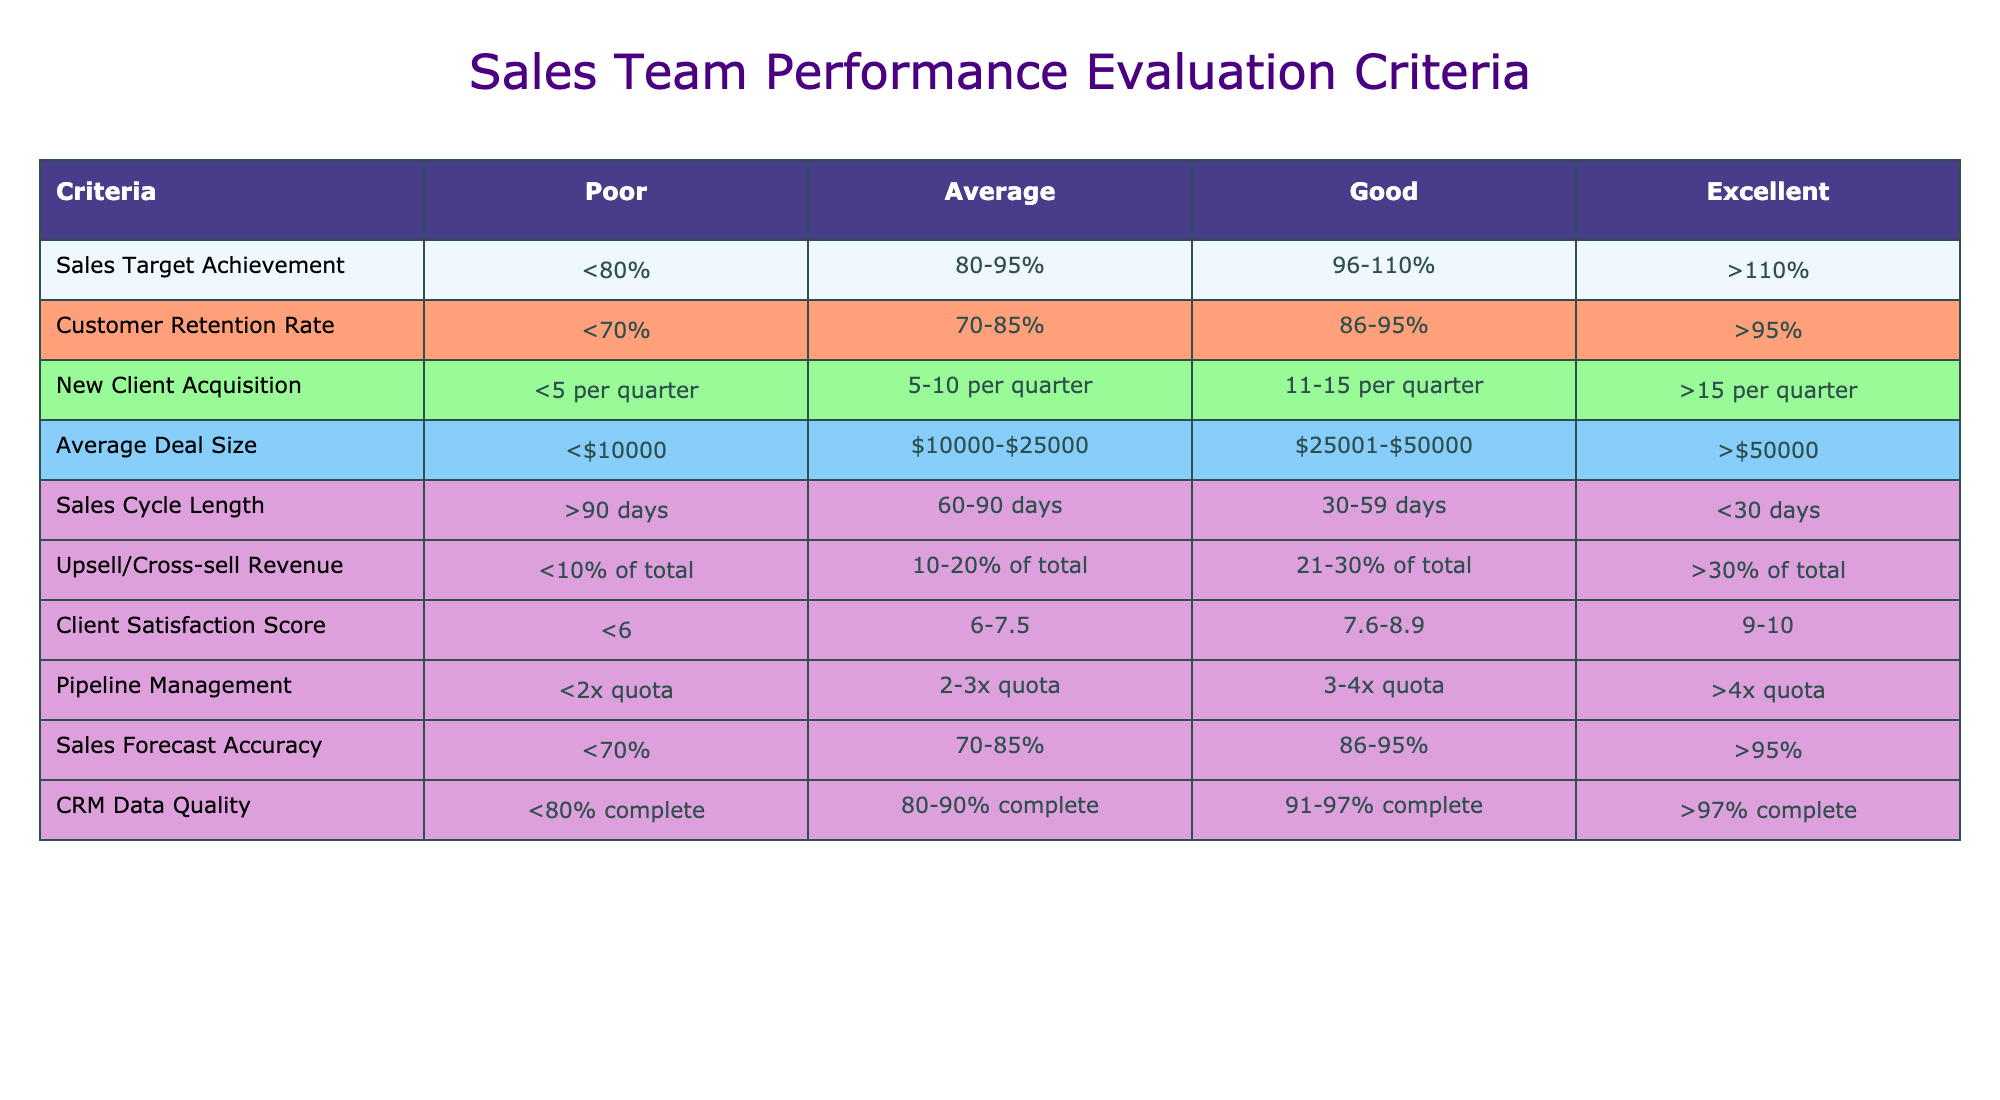What is the achievement category for a sales target of 85%? According to the table, a sales target achievement of 85% falls within the "Average" category, as it is between 80% and 95%.
Answer: Average What is the client satisfaction score that corresponds to “good” performance? The table states that a "Good" client satisfaction score is between 7.6 and 8.9.
Answer: 7.6-8.9 If a sales team retains 88% of its customers, how would you categorize their retention rate? A customer retention rate of 88% is between 86% and 95%, thus it is categorized as "Good".
Answer: Good Is a new client acquisition rate of 4 clients per quarter considered sufficient? The table indicates that acquiring fewer than 5 clients per quarter is categorized as "Poor."
Answer: No What is the average deal size category for deals worth $30,000? The table shows that a deal size of $30,000 falls within the "Good" category, as it is between $25,001 and $50,000.
Answer: Good If the sales cycle length is 45 days, what performance category does it fall into? A sales cycle length of 45 days is classified as "Good," which is defined as between 30 and 59 days.
Answer: Good What is the average deal size for a sales team that has an upsell revenue proportion of 15%? An upsell/cross-sell revenue proportion of 15% fits the "Average" category, indicating that this sales team falls between 10% to 20% of total revenue.
Answer: Average If two sales team members manage to achieve a pipeline management of 3x quota, how would that be categorized? According to the table, managing a pipeline of 3x quota is categorized as "Good," which ranges from 3x to 4x quota.
Answer: Good What is the sales forecast accuracy that would be considered "Excellent"? The table specifies that a sales forecast accuracy greater than 95% is categorized as "Excellent."
Answer: >95% 